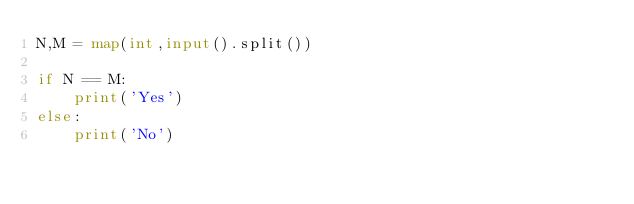Convert code to text. <code><loc_0><loc_0><loc_500><loc_500><_Python_>N,M = map(int,input().split())

if N == M:
    print('Yes')
else:
    print('No')</code> 